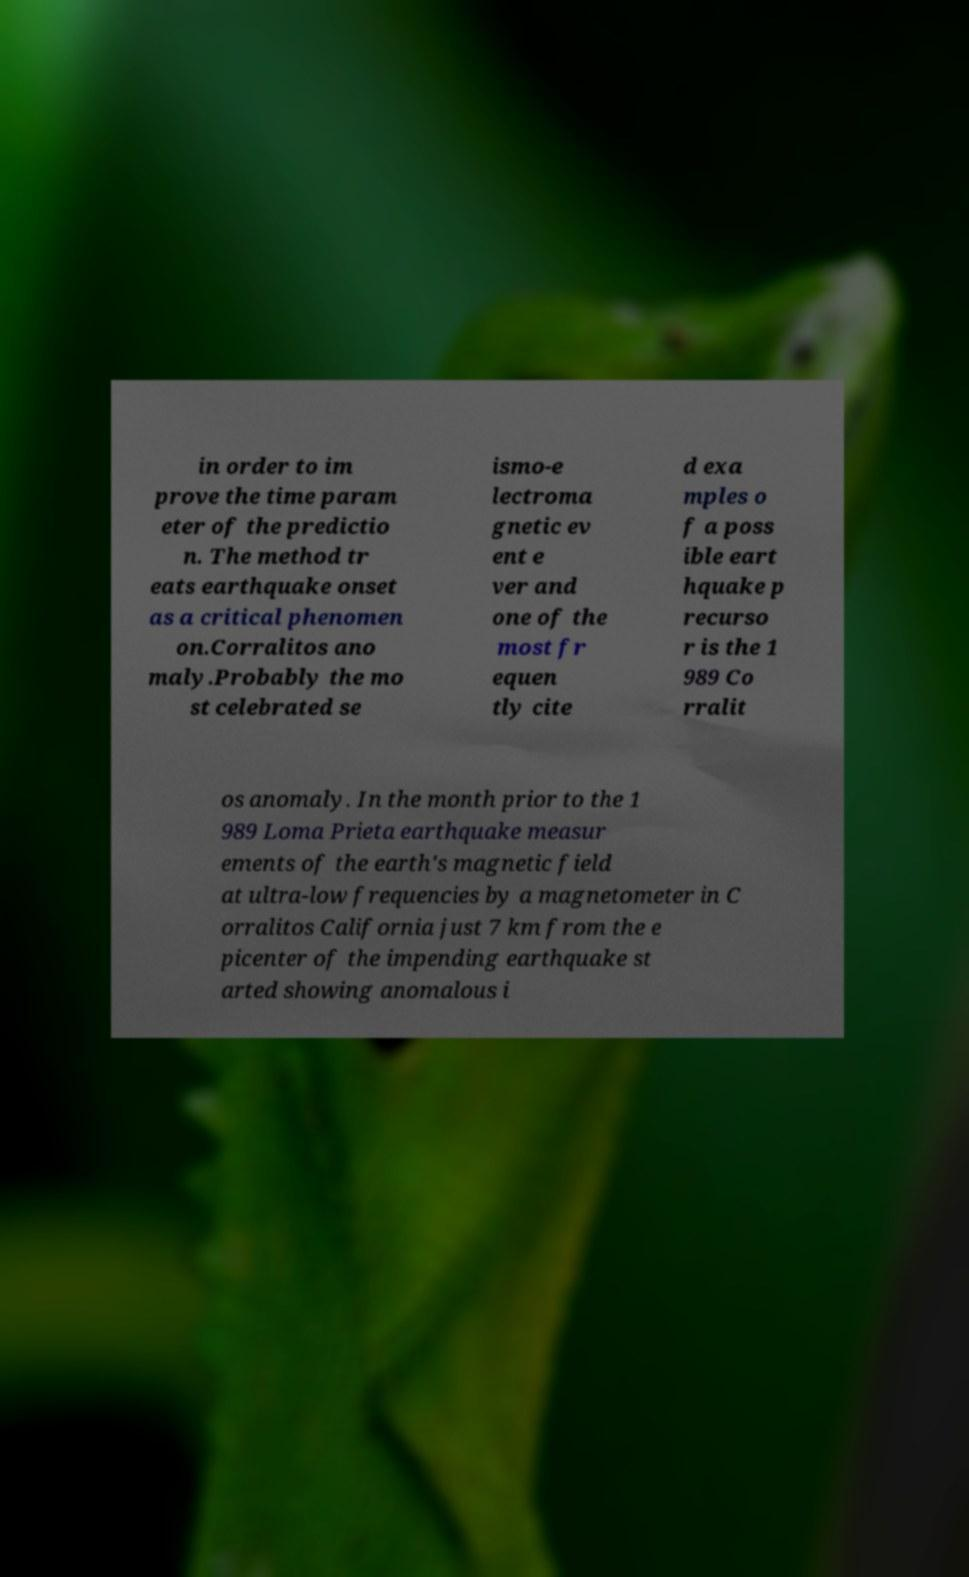Please read and relay the text visible in this image. What does it say? in order to im prove the time param eter of the predictio n. The method tr eats earthquake onset as a critical phenomen on.Corralitos ano maly.Probably the mo st celebrated se ismo-e lectroma gnetic ev ent e ver and one of the most fr equen tly cite d exa mples o f a poss ible eart hquake p recurso r is the 1 989 Co rralit os anomaly. In the month prior to the 1 989 Loma Prieta earthquake measur ements of the earth's magnetic field at ultra-low frequencies by a magnetometer in C orralitos California just 7 km from the e picenter of the impending earthquake st arted showing anomalous i 